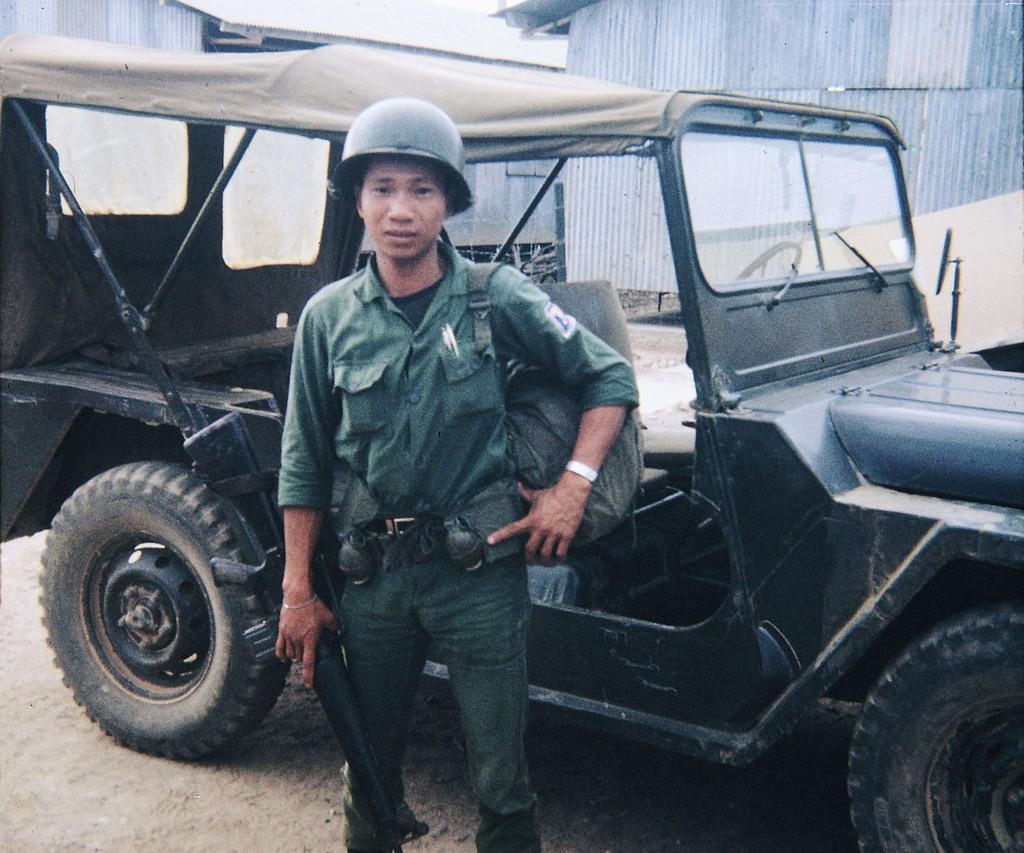Can you describe this image briefly? The man in the uniform who is wearing a helmet is standing and he is holding something in his hand. Behind him, we see a jeep in black color. Behind that, there are buildings and shed. At the bottom of the picture, we see the sand. 